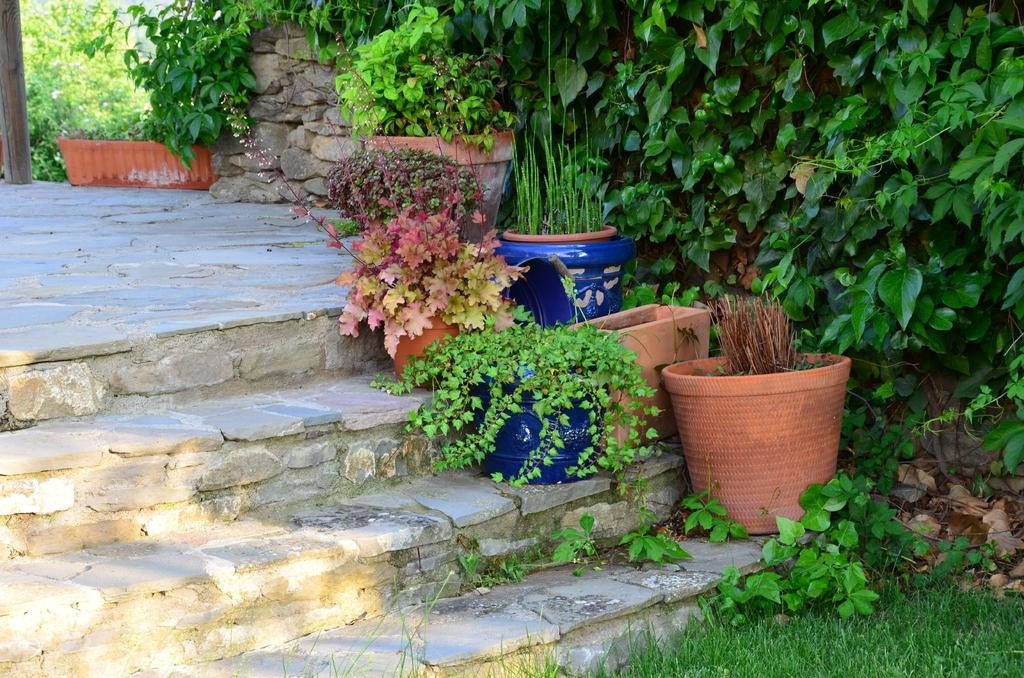What can be seen in the foreground of the picture? In the foreground of the picture, there are flower pots, plants, a staircase, and grass. Can you describe the top part of the picture? In the top part of the picture, there are trees, a wall, and plants. What type of vegetation is present in the picture? The picture contains plants, trees, and grass. How does the pump work in the picture? There is no pump present in the picture. Can you describe the flame coming from the tree in the picture? There is no flame or tree with a flame in the picture. 